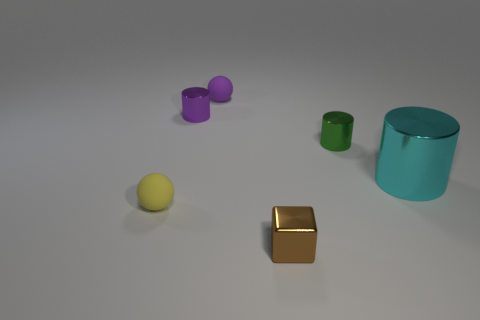Is there a cyan cylinder that has the same size as the purple metallic thing?
Your answer should be very brief. No. There is a cyan thing; is its shape the same as the tiny metal thing that is behind the green metal cylinder?
Keep it short and to the point. Yes. What number of blocks are yellow rubber objects or brown things?
Make the answer very short. 1. The tiny block has what color?
Give a very brief answer. Brown. Is the number of red shiny objects greater than the number of tiny rubber spheres?
Make the answer very short. No. How many objects are shiny cylinders left of the tiny green metallic thing or big purple metal balls?
Your answer should be compact. 1. Does the brown object have the same material as the tiny purple ball?
Provide a short and direct response. No. What size is the other purple object that is the same shape as the large metal object?
Give a very brief answer. Small. Do the metal thing in front of the cyan cylinder and the rubber object in front of the cyan metal thing have the same shape?
Your answer should be compact. No. There is a brown block; is its size the same as the ball in front of the cyan metallic cylinder?
Make the answer very short. Yes. 